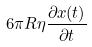Convert formula to latex. <formula><loc_0><loc_0><loc_500><loc_500>6 \pi R \eta \frac { \partial x ( t ) } { \partial t }</formula> 